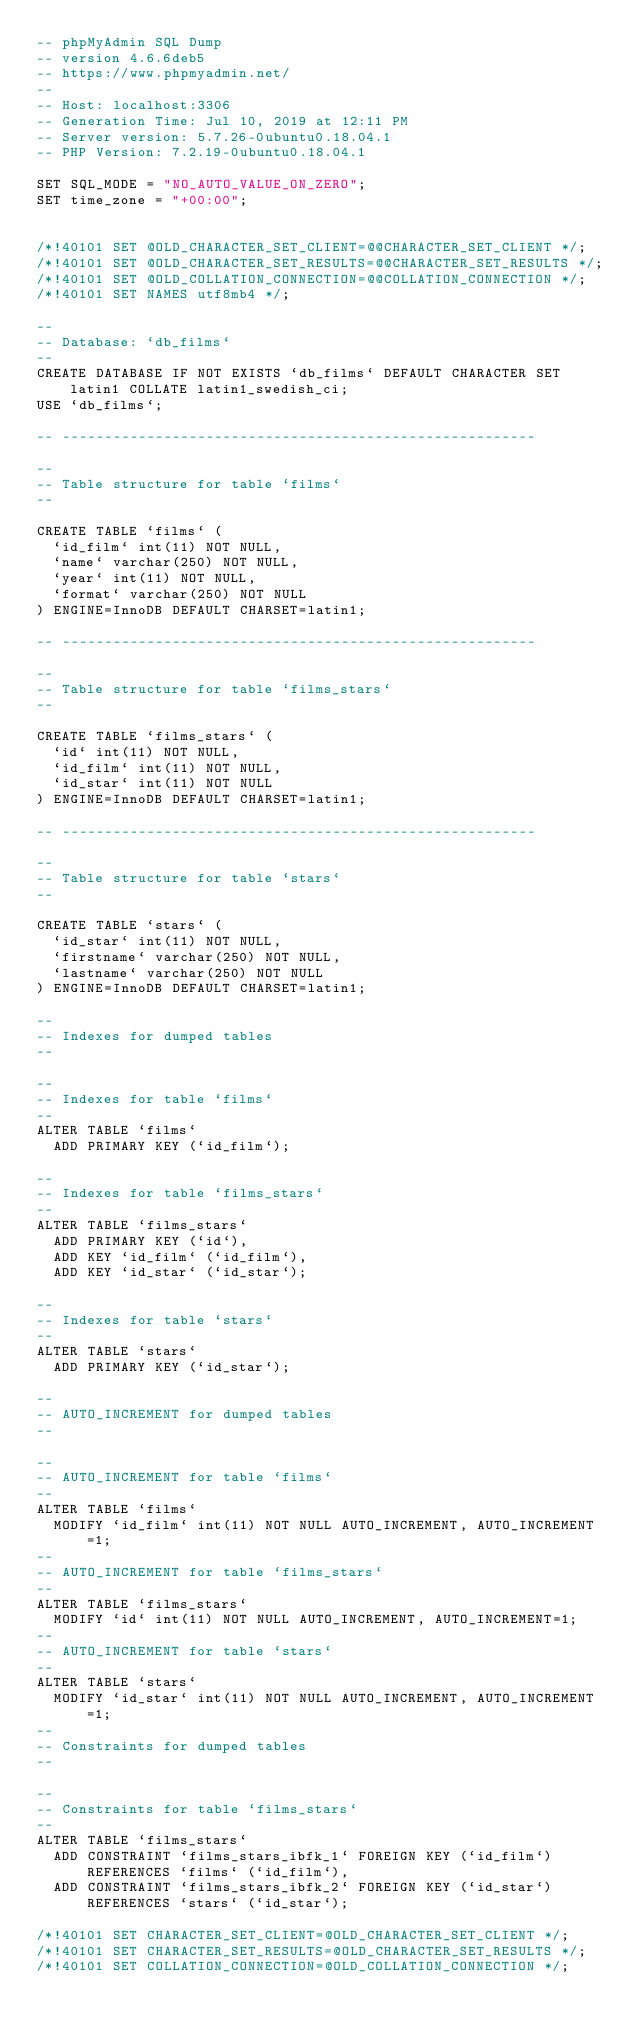<code> <loc_0><loc_0><loc_500><loc_500><_SQL_>-- phpMyAdmin SQL Dump
-- version 4.6.6deb5
-- https://www.phpmyadmin.net/
--
-- Host: localhost:3306
-- Generation Time: Jul 10, 2019 at 12:11 PM
-- Server version: 5.7.26-0ubuntu0.18.04.1
-- PHP Version: 7.2.19-0ubuntu0.18.04.1

SET SQL_MODE = "NO_AUTO_VALUE_ON_ZERO";
SET time_zone = "+00:00";


/*!40101 SET @OLD_CHARACTER_SET_CLIENT=@@CHARACTER_SET_CLIENT */;
/*!40101 SET @OLD_CHARACTER_SET_RESULTS=@@CHARACTER_SET_RESULTS */;
/*!40101 SET @OLD_COLLATION_CONNECTION=@@COLLATION_CONNECTION */;
/*!40101 SET NAMES utf8mb4 */;

--
-- Database: `db_films`
--
CREATE DATABASE IF NOT EXISTS `db_films` DEFAULT CHARACTER SET latin1 COLLATE latin1_swedish_ci;
USE `db_films`;

-- --------------------------------------------------------

--
-- Table structure for table `films`
--

CREATE TABLE `films` (
  `id_film` int(11) NOT NULL,
  `name` varchar(250) NOT NULL,
  `year` int(11) NOT NULL,
  `format` varchar(250) NOT NULL
) ENGINE=InnoDB DEFAULT CHARSET=latin1;

-- --------------------------------------------------------

--
-- Table structure for table `films_stars`
--

CREATE TABLE `films_stars` (
  `id` int(11) NOT NULL,
  `id_film` int(11) NOT NULL,
  `id_star` int(11) NOT NULL
) ENGINE=InnoDB DEFAULT CHARSET=latin1;

-- --------------------------------------------------------

--
-- Table structure for table `stars`
--

CREATE TABLE `stars` (
  `id_star` int(11) NOT NULL,
  `firstname` varchar(250) NOT NULL,
  `lastname` varchar(250) NOT NULL
) ENGINE=InnoDB DEFAULT CHARSET=latin1;

--
-- Indexes for dumped tables
--

--
-- Indexes for table `films`
--
ALTER TABLE `films`
  ADD PRIMARY KEY (`id_film`);

--
-- Indexes for table `films_stars`
--
ALTER TABLE `films_stars`
  ADD PRIMARY KEY (`id`),
  ADD KEY `id_film` (`id_film`),
  ADD KEY `id_star` (`id_star`);

--
-- Indexes for table `stars`
--
ALTER TABLE `stars`
  ADD PRIMARY KEY (`id_star`);

--
-- AUTO_INCREMENT for dumped tables
--

--
-- AUTO_INCREMENT for table `films`
--
ALTER TABLE `films`
  MODIFY `id_film` int(11) NOT NULL AUTO_INCREMENT, AUTO_INCREMENT=1;
--
-- AUTO_INCREMENT for table `films_stars`
--
ALTER TABLE `films_stars`
  MODIFY `id` int(11) NOT NULL AUTO_INCREMENT, AUTO_INCREMENT=1;
--
-- AUTO_INCREMENT for table `stars`
--
ALTER TABLE `stars`
  MODIFY `id_star` int(11) NOT NULL AUTO_INCREMENT, AUTO_INCREMENT=1;
--
-- Constraints for dumped tables
--

--
-- Constraints for table `films_stars`
--
ALTER TABLE `films_stars`
  ADD CONSTRAINT `films_stars_ibfk_1` FOREIGN KEY (`id_film`) REFERENCES `films` (`id_film`),
  ADD CONSTRAINT `films_stars_ibfk_2` FOREIGN KEY (`id_star`) REFERENCES `stars` (`id_star`);

/*!40101 SET CHARACTER_SET_CLIENT=@OLD_CHARACTER_SET_CLIENT */;
/*!40101 SET CHARACTER_SET_RESULTS=@OLD_CHARACTER_SET_RESULTS */;
/*!40101 SET COLLATION_CONNECTION=@OLD_COLLATION_CONNECTION */;
</code> 